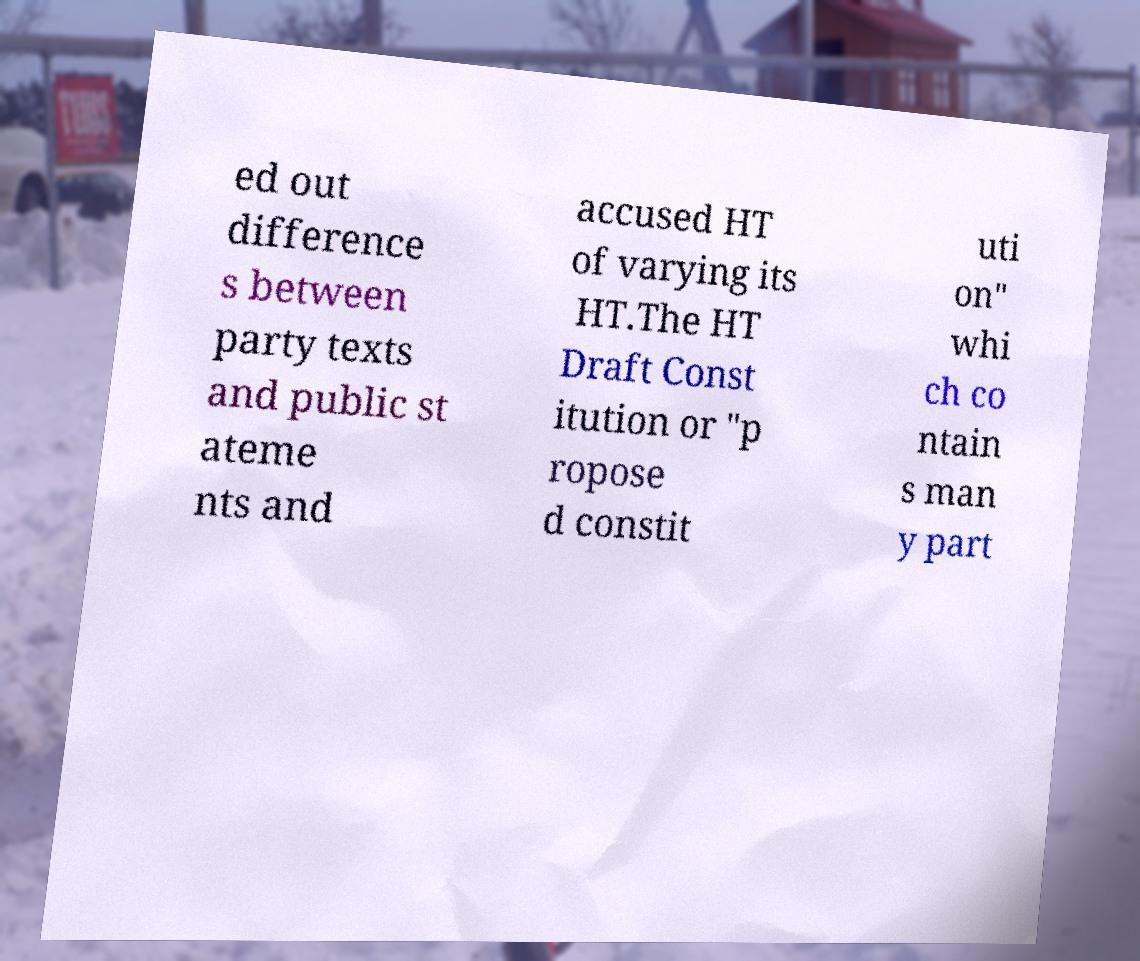Could you extract and type out the text from this image? ed out difference s between party texts and public st ateme nts and accused HT of varying its HT.The HT Draft Const itution or "p ropose d constit uti on" whi ch co ntain s man y part 